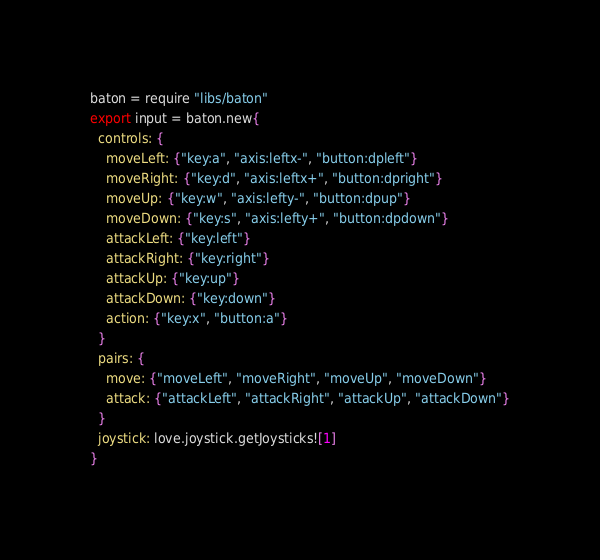Convert code to text. <code><loc_0><loc_0><loc_500><loc_500><_MoonScript_>baton = require "libs/baton"
export input = baton.new{
  controls: {
    moveLeft: {"key:a", "axis:leftx-", "button:dpleft"}
    moveRight: {"key:d", "axis:leftx+", "button:dpright"}
    moveUp: {"key:w", "axis:lefty-", "button:dpup"}
    moveDown: {"key:s", "axis:lefty+", "button:dpdown"}
    attackLeft: {"key:left"}
    attackRight: {"key:right"}
    attackUp: {"key:up"}
    attackDown: {"key:down"}
    action: {"key:x", "button:a"}
  }
  pairs: {
    move: {"moveLeft", "moveRight", "moveUp", "moveDown"}
    attack: {"attackLeft", "attackRight", "attackUp", "attackDown"}
  }
  joystick: love.joystick.getJoysticks![1]
}</code> 